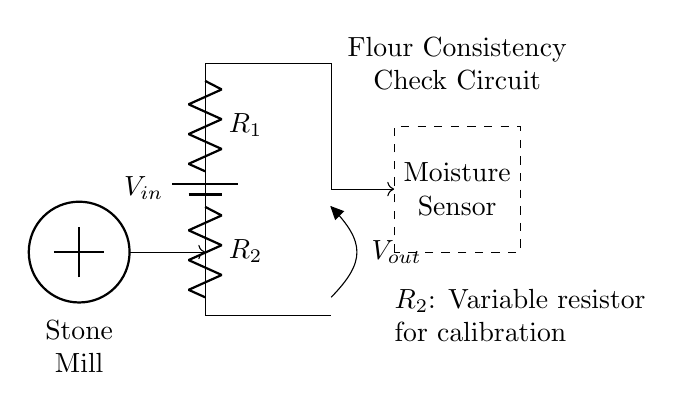What is the purpose of the variable resistor R2? The variable resistor R2 is used for calibration, allowing the user to adjust the resistance and thus modify the output voltage to match the moisture levels appropriately.
Answer: Calibration What does Vout represent in this circuit? Vout represents the output voltage across the moisture sensor, indicating the moisture level of the flour based on the voltage divider formula.
Answer: Output voltage Which two components form the voltage divider? R1 and R2 form the voltage divider; they are arranged in series with the input voltage applied across them, allowing for a split of the input voltage based on their resistances.
Answer: R1 and R2 What type of signal does the moisture sensor provide? The moisture sensor provides an analog signal, which varies the output voltage depending on the moisture content detected in the flour.
Answer: Analog signal How does the arrangement of R1 and R2 affect Vout? The Vout is affected by the ratio of R1 to R2 as per the voltage divider rule. If R2 is increased, Vout decreases, and if R1 is increased, Vout increases, impacting the sensor's reading.
Answer: Ratio of resistances What does the dashed rectangle symbolize? The dashed rectangle represents the moisture sensor, which is the component that detects and measures the moisture content in the flour being processed.
Answer: Moisture Sensor What role does the stone mill play in this circuit? The stone mill is the source of the flour, which is the substance being tested for moisture content; its output is the flour that the sensor measures.
Answer: Source of flour 